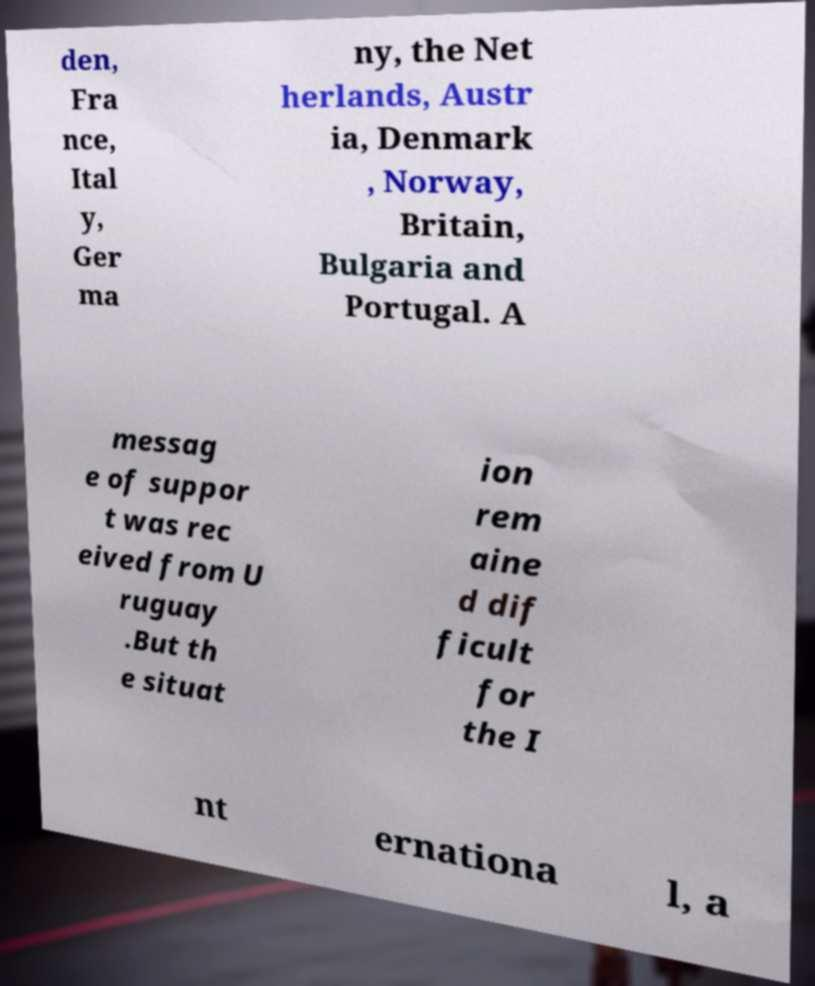Please read and relay the text visible in this image. What does it say? den, Fra nce, Ital y, Ger ma ny, the Net herlands, Austr ia, Denmark , Norway, Britain, Bulgaria and Portugal. A messag e of suppor t was rec eived from U ruguay .But th e situat ion rem aine d dif ficult for the I nt ernationa l, a 